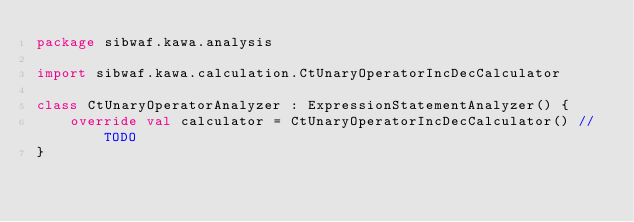Convert code to text. <code><loc_0><loc_0><loc_500><loc_500><_Kotlin_>package sibwaf.kawa.analysis

import sibwaf.kawa.calculation.CtUnaryOperatorIncDecCalculator

class CtUnaryOperatorAnalyzer : ExpressionStatementAnalyzer() {
    override val calculator = CtUnaryOperatorIncDecCalculator() // TODO
}</code> 